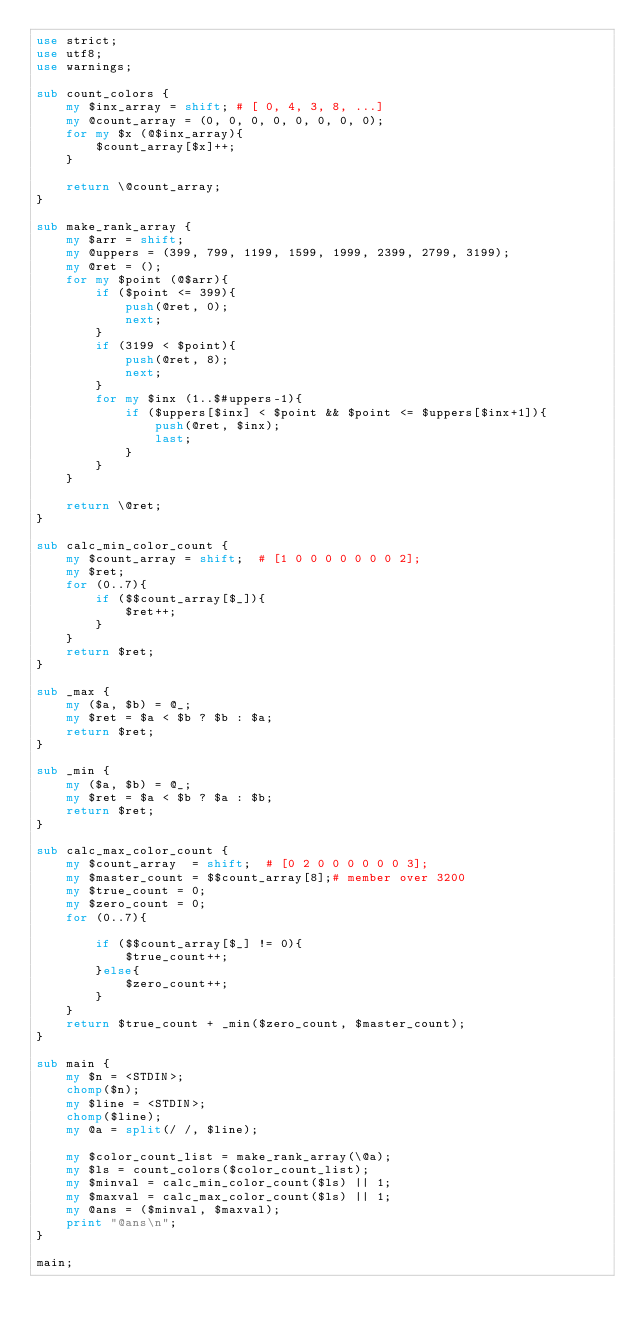Convert code to text. <code><loc_0><loc_0><loc_500><loc_500><_Perl_>use strict;
use utf8;
use warnings;

sub count_colors {
    my $inx_array = shift; # [ 0, 4, 3, 8, ...]
    my @count_array = (0, 0, 0, 0, 0, 0, 0, 0);
    for my $x (@$inx_array){
        $count_array[$x]++;
    }

    return \@count_array;
}

sub make_rank_array {
    my $arr = shift;
    my @uppers = (399, 799, 1199, 1599, 1999, 2399, 2799, 3199);
    my @ret = ();
    for my $point (@$arr){
        if ($point <= 399){
            push(@ret, 0);
            next;
        }
        if (3199 < $point){
            push(@ret, 8);
            next;
        }
        for my $inx (1..$#uppers-1){
            if ($uppers[$inx] < $point && $point <= $uppers[$inx+1]){
                push(@ret, $inx);
                last;
            }
        }
    }

    return \@ret;
}

sub calc_min_color_count {
    my $count_array = shift;  # [1 0 0 0 0 0 0 0 2];
    my $ret;
    for (0..7){
        if ($$count_array[$_]){
            $ret++;
        }
    }
    return $ret;
}

sub _max {
    my ($a, $b) = @_;
    my $ret = $a < $b ? $b : $a;
    return $ret;
}

sub _min {
    my ($a, $b) = @_;
    my $ret = $a < $b ? $a : $b;
    return $ret;
}

sub calc_max_color_count {
    my $count_array  = shift;  # [0 2 0 0 0 0 0 0 3];
    my $master_count = $$count_array[8];# member over 3200
    my $true_count = 0;
    my $zero_count = 0;
    for (0..7){
       
        if ($$count_array[$_] != 0){
            $true_count++;
        }else{    
            $zero_count++;
        }
    }
    return $true_count + _min($zero_count, $master_count);
}

sub main {
    my $n = <STDIN>;
    chomp($n);
    my $line = <STDIN>;
    chomp($line);
    my @a = split(/ /, $line);

    my $color_count_list = make_rank_array(\@a);
    my $ls = count_colors($color_count_list);
    my $minval = calc_min_color_count($ls) || 1;
    my $maxval = calc_max_color_count($ls) || 1;
    my @ans = ($minval, $maxval);
    print "@ans\n";
}

main;
</code> 